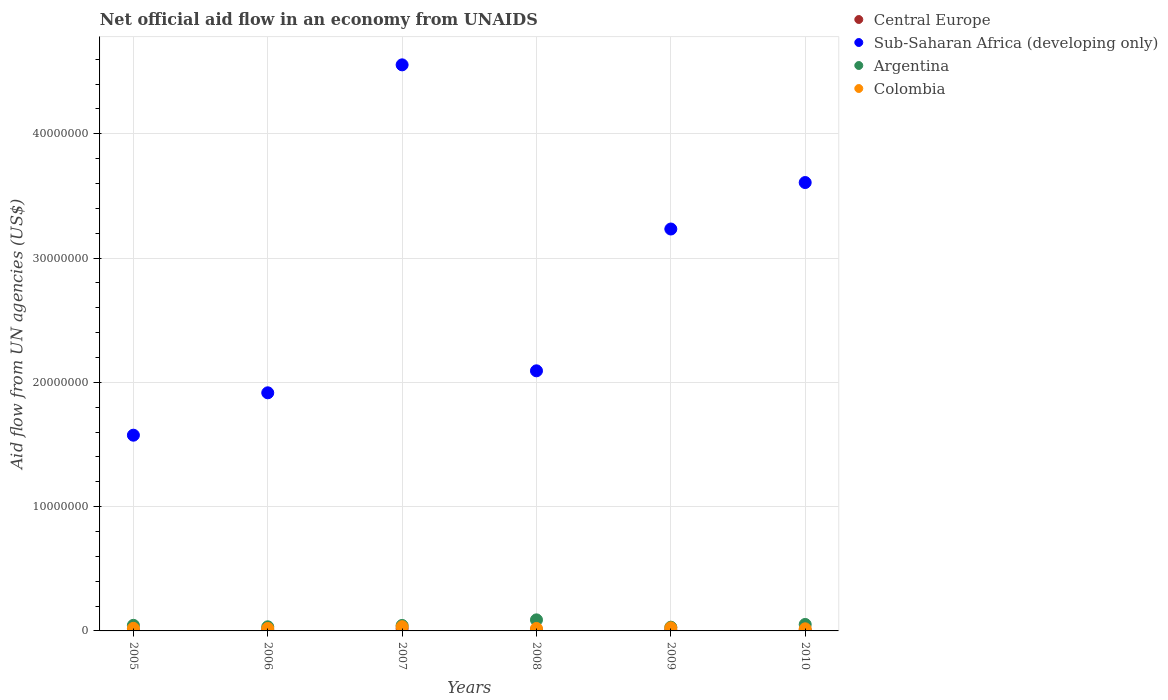How many different coloured dotlines are there?
Your answer should be compact. 4. What is the net official aid flow in Argentina in 2010?
Make the answer very short. 5.20e+05. Across all years, what is the maximum net official aid flow in Argentina?
Ensure brevity in your answer.  8.90e+05. Across all years, what is the minimum net official aid flow in Argentina?
Offer a terse response. 3.00e+05. In which year was the net official aid flow in Sub-Saharan Africa (developing only) maximum?
Your answer should be very brief. 2007. What is the total net official aid flow in Colombia in the graph?
Your response must be concise. 1.37e+06. What is the difference between the net official aid flow in Argentina in 2007 and that in 2009?
Offer a terse response. 1.40e+05. What is the average net official aid flow in Colombia per year?
Your answer should be very brief. 2.28e+05. In the year 2006, what is the difference between the net official aid flow in Argentina and net official aid flow in Colombia?
Provide a succinct answer. 1.30e+05. What is the ratio of the net official aid flow in Central Europe in 2008 to that in 2010?
Ensure brevity in your answer.  1.14. Is the net official aid flow in Colombia in 2006 less than that in 2007?
Give a very brief answer. Yes. What is the difference between the highest and the lowest net official aid flow in Argentina?
Your response must be concise. 5.90e+05. In how many years, is the net official aid flow in Central Europe greater than the average net official aid flow in Central Europe taken over all years?
Keep it short and to the point. 1. Is it the case that in every year, the sum of the net official aid flow in Sub-Saharan Africa (developing only) and net official aid flow in Central Europe  is greater than the sum of net official aid flow in Colombia and net official aid flow in Argentina?
Ensure brevity in your answer.  Yes. Is it the case that in every year, the sum of the net official aid flow in Argentina and net official aid flow in Colombia  is greater than the net official aid flow in Central Europe?
Give a very brief answer. Yes. Is the net official aid flow in Colombia strictly greater than the net official aid flow in Argentina over the years?
Keep it short and to the point. No. How many dotlines are there?
Your answer should be compact. 4. How many years are there in the graph?
Provide a short and direct response. 6. Where does the legend appear in the graph?
Your answer should be compact. Top right. How many legend labels are there?
Your answer should be very brief. 4. What is the title of the graph?
Provide a short and direct response. Net official aid flow in an economy from UNAIDS. What is the label or title of the X-axis?
Your answer should be compact. Years. What is the label or title of the Y-axis?
Your answer should be very brief. Aid flow from UN agencies (US$). What is the Aid flow from UN agencies (US$) of Central Europe in 2005?
Make the answer very short. 5.00e+04. What is the Aid flow from UN agencies (US$) in Sub-Saharan Africa (developing only) in 2005?
Offer a terse response. 1.58e+07. What is the Aid flow from UN agencies (US$) of Argentina in 2005?
Offer a terse response. 4.50e+05. What is the Aid flow from UN agencies (US$) in Sub-Saharan Africa (developing only) in 2006?
Provide a succinct answer. 1.92e+07. What is the Aid flow from UN agencies (US$) in Argentina in 2006?
Keep it short and to the point. 3.30e+05. What is the Aid flow from UN agencies (US$) of Colombia in 2006?
Provide a short and direct response. 2.00e+05. What is the Aid flow from UN agencies (US$) in Central Europe in 2007?
Give a very brief answer. 1.80e+05. What is the Aid flow from UN agencies (US$) of Sub-Saharan Africa (developing only) in 2007?
Keep it short and to the point. 4.56e+07. What is the Aid flow from UN agencies (US$) in Central Europe in 2008?
Your response must be concise. 8.00e+04. What is the Aid flow from UN agencies (US$) in Sub-Saharan Africa (developing only) in 2008?
Give a very brief answer. 2.09e+07. What is the Aid flow from UN agencies (US$) in Argentina in 2008?
Make the answer very short. 8.90e+05. What is the Aid flow from UN agencies (US$) of Sub-Saharan Africa (developing only) in 2009?
Offer a terse response. 3.23e+07. What is the Aid flow from UN agencies (US$) in Argentina in 2009?
Offer a terse response. 3.00e+05. What is the Aid flow from UN agencies (US$) in Colombia in 2009?
Provide a succinct answer. 2.50e+05. What is the Aid flow from UN agencies (US$) in Central Europe in 2010?
Your answer should be very brief. 7.00e+04. What is the Aid flow from UN agencies (US$) in Sub-Saharan Africa (developing only) in 2010?
Offer a terse response. 3.61e+07. What is the Aid flow from UN agencies (US$) in Argentina in 2010?
Keep it short and to the point. 5.20e+05. What is the Aid flow from UN agencies (US$) in Colombia in 2010?
Offer a very short reply. 1.70e+05. Across all years, what is the maximum Aid flow from UN agencies (US$) in Sub-Saharan Africa (developing only)?
Make the answer very short. 4.56e+07. Across all years, what is the maximum Aid flow from UN agencies (US$) in Argentina?
Your response must be concise. 8.90e+05. Across all years, what is the maximum Aid flow from UN agencies (US$) in Colombia?
Ensure brevity in your answer.  3.40e+05. Across all years, what is the minimum Aid flow from UN agencies (US$) in Sub-Saharan Africa (developing only)?
Provide a short and direct response. 1.58e+07. Across all years, what is the minimum Aid flow from UN agencies (US$) of Argentina?
Give a very brief answer. 3.00e+05. What is the total Aid flow from UN agencies (US$) of Central Europe in the graph?
Your answer should be compact. 5.30e+05. What is the total Aid flow from UN agencies (US$) in Sub-Saharan Africa (developing only) in the graph?
Give a very brief answer. 1.70e+08. What is the total Aid flow from UN agencies (US$) of Argentina in the graph?
Offer a very short reply. 2.93e+06. What is the total Aid flow from UN agencies (US$) in Colombia in the graph?
Provide a succinct answer. 1.37e+06. What is the difference between the Aid flow from UN agencies (US$) in Sub-Saharan Africa (developing only) in 2005 and that in 2006?
Your answer should be very brief. -3.41e+06. What is the difference between the Aid flow from UN agencies (US$) of Argentina in 2005 and that in 2006?
Provide a short and direct response. 1.20e+05. What is the difference between the Aid flow from UN agencies (US$) in Central Europe in 2005 and that in 2007?
Give a very brief answer. -1.30e+05. What is the difference between the Aid flow from UN agencies (US$) in Sub-Saharan Africa (developing only) in 2005 and that in 2007?
Ensure brevity in your answer.  -2.98e+07. What is the difference between the Aid flow from UN agencies (US$) in Argentina in 2005 and that in 2007?
Your answer should be very brief. 10000. What is the difference between the Aid flow from UN agencies (US$) of Central Europe in 2005 and that in 2008?
Your answer should be very brief. -3.00e+04. What is the difference between the Aid flow from UN agencies (US$) of Sub-Saharan Africa (developing only) in 2005 and that in 2008?
Keep it short and to the point. -5.18e+06. What is the difference between the Aid flow from UN agencies (US$) of Argentina in 2005 and that in 2008?
Your answer should be very brief. -4.40e+05. What is the difference between the Aid flow from UN agencies (US$) in Sub-Saharan Africa (developing only) in 2005 and that in 2009?
Ensure brevity in your answer.  -1.66e+07. What is the difference between the Aid flow from UN agencies (US$) of Argentina in 2005 and that in 2009?
Your answer should be compact. 1.50e+05. What is the difference between the Aid flow from UN agencies (US$) in Colombia in 2005 and that in 2009?
Your answer should be compact. -4.00e+04. What is the difference between the Aid flow from UN agencies (US$) of Sub-Saharan Africa (developing only) in 2005 and that in 2010?
Your response must be concise. -2.03e+07. What is the difference between the Aid flow from UN agencies (US$) in Argentina in 2005 and that in 2010?
Give a very brief answer. -7.00e+04. What is the difference between the Aid flow from UN agencies (US$) in Sub-Saharan Africa (developing only) in 2006 and that in 2007?
Ensure brevity in your answer.  -2.64e+07. What is the difference between the Aid flow from UN agencies (US$) of Argentina in 2006 and that in 2007?
Offer a very short reply. -1.10e+05. What is the difference between the Aid flow from UN agencies (US$) of Colombia in 2006 and that in 2007?
Keep it short and to the point. -1.40e+05. What is the difference between the Aid flow from UN agencies (US$) in Sub-Saharan Africa (developing only) in 2006 and that in 2008?
Your answer should be compact. -1.77e+06. What is the difference between the Aid flow from UN agencies (US$) of Argentina in 2006 and that in 2008?
Provide a succinct answer. -5.60e+05. What is the difference between the Aid flow from UN agencies (US$) of Colombia in 2006 and that in 2008?
Give a very brief answer. 0. What is the difference between the Aid flow from UN agencies (US$) in Central Europe in 2006 and that in 2009?
Your answer should be compact. 10000. What is the difference between the Aid flow from UN agencies (US$) of Sub-Saharan Africa (developing only) in 2006 and that in 2009?
Provide a short and direct response. -1.32e+07. What is the difference between the Aid flow from UN agencies (US$) in Colombia in 2006 and that in 2009?
Your response must be concise. -5.00e+04. What is the difference between the Aid flow from UN agencies (US$) in Sub-Saharan Africa (developing only) in 2006 and that in 2010?
Make the answer very short. -1.69e+07. What is the difference between the Aid flow from UN agencies (US$) in Argentina in 2006 and that in 2010?
Provide a short and direct response. -1.90e+05. What is the difference between the Aid flow from UN agencies (US$) of Central Europe in 2007 and that in 2008?
Offer a terse response. 1.00e+05. What is the difference between the Aid flow from UN agencies (US$) of Sub-Saharan Africa (developing only) in 2007 and that in 2008?
Your response must be concise. 2.46e+07. What is the difference between the Aid flow from UN agencies (US$) in Argentina in 2007 and that in 2008?
Your response must be concise. -4.50e+05. What is the difference between the Aid flow from UN agencies (US$) of Central Europe in 2007 and that in 2009?
Offer a very short reply. 1.10e+05. What is the difference between the Aid flow from UN agencies (US$) of Sub-Saharan Africa (developing only) in 2007 and that in 2009?
Make the answer very short. 1.32e+07. What is the difference between the Aid flow from UN agencies (US$) in Argentina in 2007 and that in 2009?
Make the answer very short. 1.40e+05. What is the difference between the Aid flow from UN agencies (US$) in Sub-Saharan Africa (developing only) in 2007 and that in 2010?
Provide a succinct answer. 9.47e+06. What is the difference between the Aid flow from UN agencies (US$) in Central Europe in 2008 and that in 2009?
Keep it short and to the point. 10000. What is the difference between the Aid flow from UN agencies (US$) of Sub-Saharan Africa (developing only) in 2008 and that in 2009?
Ensure brevity in your answer.  -1.14e+07. What is the difference between the Aid flow from UN agencies (US$) in Argentina in 2008 and that in 2009?
Ensure brevity in your answer.  5.90e+05. What is the difference between the Aid flow from UN agencies (US$) in Colombia in 2008 and that in 2009?
Provide a short and direct response. -5.00e+04. What is the difference between the Aid flow from UN agencies (US$) in Central Europe in 2008 and that in 2010?
Provide a short and direct response. 10000. What is the difference between the Aid flow from UN agencies (US$) of Sub-Saharan Africa (developing only) in 2008 and that in 2010?
Keep it short and to the point. -1.52e+07. What is the difference between the Aid flow from UN agencies (US$) in Argentina in 2008 and that in 2010?
Offer a very short reply. 3.70e+05. What is the difference between the Aid flow from UN agencies (US$) in Colombia in 2008 and that in 2010?
Give a very brief answer. 3.00e+04. What is the difference between the Aid flow from UN agencies (US$) of Sub-Saharan Africa (developing only) in 2009 and that in 2010?
Make the answer very short. -3.74e+06. What is the difference between the Aid flow from UN agencies (US$) of Argentina in 2009 and that in 2010?
Your answer should be very brief. -2.20e+05. What is the difference between the Aid flow from UN agencies (US$) of Central Europe in 2005 and the Aid flow from UN agencies (US$) of Sub-Saharan Africa (developing only) in 2006?
Offer a terse response. -1.91e+07. What is the difference between the Aid flow from UN agencies (US$) in Central Europe in 2005 and the Aid flow from UN agencies (US$) in Argentina in 2006?
Your response must be concise. -2.80e+05. What is the difference between the Aid flow from UN agencies (US$) of Sub-Saharan Africa (developing only) in 2005 and the Aid flow from UN agencies (US$) of Argentina in 2006?
Ensure brevity in your answer.  1.54e+07. What is the difference between the Aid flow from UN agencies (US$) in Sub-Saharan Africa (developing only) in 2005 and the Aid flow from UN agencies (US$) in Colombia in 2006?
Give a very brief answer. 1.56e+07. What is the difference between the Aid flow from UN agencies (US$) in Central Europe in 2005 and the Aid flow from UN agencies (US$) in Sub-Saharan Africa (developing only) in 2007?
Make the answer very short. -4.55e+07. What is the difference between the Aid flow from UN agencies (US$) of Central Europe in 2005 and the Aid flow from UN agencies (US$) of Argentina in 2007?
Ensure brevity in your answer.  -3.90e+05. What is the difference between the Aid flow from UN agencies (US$) of Sub-Saharan Africa (developing only) in 2005 and the Aid flow from UN agencies (US$) of Argentina in 2007?
Your response must be concise. 1.53e+07. What is the difference between the Aid flow from UN agencies (US$) of Sub-Saharan Africa (developing only) in 2005 and the Aid flow from UN agencies (US$) of Colombia in 2007?
Your response must be concise. 1.54e+07. What is the difference between the Aid flow from UN agencies (US$) of Argentina in 2005 and the Aid flow from UN agencies (US$) of Colombia in 2007?
Make the answer very short. 1.10e+05. What is the difference between the Aid flow from UN agencies (US$) of Central Europe in 2005 and the Aid flow from UN agencies (US$) of Sub-Saharan Africa (developing only) in 2008?
Provide a succinct answer. -2.09e+07. What is the difference between the Aid flow from UN agencies (US$) in Central Europe in 2005 and the Aid flow from UN agencies (US$) in Argentina in 2008?
Give a very brief answer. -8.40e+05. What is the difference between the Aid flow from UN agencies (US$) in Central Europe in 2005 and the Aid flow from UN agencies (US$) in Colombia in 2008?
Your response must be concise. -1.50e+05. What is the difference between the Aid flow from UN agencies (US$) of Sub-Saharan Africa (developing only) in 2005 and the Aid flow from UN agencies (US$) of Argentina in 2008?
Make the answer very short. 1.49e+07. What is the difference between the Aid flow from UN agencies (US$) of Sub-Saharan Africa (developing only) in 2005 and the Aid flow from UN agencies (US$) of Colombia in 2008?
Make the answer very short. 1.56e+07. What is the difference between the Aid flow from UN agencies (US$) in Central Europe in 2005 and the Aid flow from UN agencies (US$) in Sub-Saharan Africa (developing only) in 2009?
Offer a very short reply. -3.23e+07. What is the difference between the Aid flow from UN agencies (US$) of Central Europe in 2005 and the Aid flow from UN agencies (US$) of Colombia in 2009?
Give a very brief answer. -2.00e+05. What is the difference between the Aid flow from UN agencies (US$) in Sub-Saharan Africa (developing only) in 2005 and the Aid flow from UN agencies (US$) in Argentina in 2009?
Your response must be concise. 1.54e+07. What is the difference between the Aid flow from UN agencies (US$) of Sub-Saharan Africa (developing only) in 2005 and the Aid flow from UN agencies (US$) of Colombia in 2009?
Your answer should be compact. 1.55e+07. What is the difference between the Aid flow from UN agencies (US$) in Argentina in 2005 and the Aid flow from UN agencies (US$) in Colombia in 2009?
Keep it short and to the point. 2.00e+05. What is the difference between the Aid flow from UN agencies (US$) of Central Europe in 2005 and the Aid flow from UN agencies (US$) of Sub-Saharan Africa (developing only) in 2010?
Give a very brief answer. -3.60e+07. What is the difference between the Aid flow from UN agencies (US$) in Central Europe in 2005 and the Aid flow from UN agencies (US$) in Argentina in 2010?
Offer a terse response. -4.70e+05. What is the difference between the Aid flow from UN agencies (US$) of Sub-Saharan Africa (developing only) in 2005 and the Aid flow from UN agencies (US$) of Argentina in 2010?
Offer a terse response. 1.52e+07. What is the difference between the Aid flow from UN agencies (US$) in Sub-Saharan Africa (developing only) in 2005 and the Aid flow from UN agencies (US$) in Colombia in 2010?
Your answer should be very brief. 1.56e+07. What is the difference between the Aid flow from UN agencies (US$) in Central Europe in 2006 and the Aid flow from UN agencies (US$) in Sub-Saharan Africa (developing only) in 2007?
Give a very brief answer. -4.55e+07. What is the difference between the Aid flow from UN agencies (US$) in Central Europe in 2006 and the Aid flow from UN agencies (US$) in Argentina in 2007?
Provide a succinct answer. -3.60e+05. What is the difference between the Aid flow from UN agencies (US$) in Sub-Saharan Africa (developing only) in 2006 and the Aid flow from UN agencies (US$) in Argentina in 2007?
Give a very brief answer. 1.87e+07. What is the difference between the Aid flow from UN agencies (US$) of Sub-Saharan Africa (developing only) in 2006 and the Aid flow from UN agencies (US$) of Colombia in 2007?
Your answer should be compact. 1.88e+07. What is the difference between the Aid flow from UN agencies (US$) in Central Europe in 2006 and the Aid flow from UN agencies (US$) in Sub-Saharan Africa (developing only) in 2008?
Give a very brief answer. -2.08e+07. What is the difference between the Aid flow from UN agencies (US$) of Central Europe in 2006 and the Aid flow from UN agencies (US$) of Argentina in 2008?
Your response must be concise. -8.10e+05. What is the difference between the Aid flow from UN agencies (US$) in Central Europe in 2006 and the Aid flow from UN agencies (US$) in Colombia in 2008?
Offer a terse response. -1.20e+05. What is the difference between the Aid flow from UN agencies (US$) of Sub-Saharan Africa (developing only) in 2006 and the Aid flow from UN agencies (US$) of Argentina in 2008?
Offer a terse response. 1.83e+07. What is the difference between the Aid flow from UN agencies (US$) in Sub-Saharan Africa (developing only) in 2006 and the Aid flow from UN agencies (US$) in Colombia in 2008?
Your answer should be very brief. 1.90e+07. What is the difference between the Aid flow from UN agencies (US$) in Argentina in 2006 and the Aid flow from UN agencies (US$) in Colombia in 2008?
Your answer should be compact. 1.30e+05. What is the difference between the Aid flow from UN agencies (US$) of Central Europe in 2006 and the Aid flow from UN agencies (US$) of Sub-Saharan Africa (developing only) in 2009?
Provide a succinct answer. -3.23e+07. What is the difference between the Aid flow from UN agencies (US$) of Central Europe in 2006 and the Aid flow from UN agencies (US$) of Argentina in 2009?
Keep it short and to the point. -2.20e+05. What is the difference between the Aid flow from UN agencies (US$) in Sub-Saharan Africa (developing only) in 2006 and the Aid flow from UN agencies (US$) in Argentina in 2009?
Make the answer very short. 1.89e+07. What is the difference between the Aid flow from UN agencies (US$) of Sub-Saharan Africa (developing only) in 2006 and the Aid flow from UN agencies (US$) of Colombia in 2009?
Make the answer very short. 1.89e+07. What is the difference between the Aid flow from UN agencies (US$) in Argentina in 2006 and the Aid flow from UN agencies (US$) in Colombia in 2009?
Offer a terse response. 8.00e+04. What is the difference between the Aid flow from UN agencies (US$) of Central Europe in 2006 and the Aid flow from UN agencies (US$) of Sub-Saharan Africa (developing only) in 2010?
Make the answer very short. -3.60e+07. What is the difference between the Aid flow from UN agencies (US$) in Central Europe in 2006 and the Aid flow from UN agencies (US$) in Argentina in 2010?
Offer a very short reply. -4.40e+05. What is the difference between the Aid flow from UN agencies (US$) of Sub-Saharan Africa (developing only) in 2006 and the Aid flow from UN agencies (US$) of Argentina in 2010?
Your response must be concise. 1.86e+07. What is the difference between the Aid flow from UN agencies (US$) in Sub-Saharan Africa (developing only) in 2006 and the Aid flow from UN agencies (US$) in Colombia in 2010?
Offer a terse response. 1.90e+07. What is the difference between the Aid flow from UN agencies (US$) of Argentina in 2006 and the Aid flow from UN agencies (US$) of Colombia in 2010?
Give a very brief answer. 1.60e+05. What is the difference between the Aid flow from UN agencies (US$) of Central Europe in 2007 and the Aid flow from UN agencies (US$) of Sub-Saharan Africa (developing only) in 2008?
Provide a short and direct response. -2.08e+07. What is the difference between the Aid flow from UN agencies (US$) of Central Europe in 2007 and the Aid flow from UN agencies (US$) of Argentina in 2008?
Provide a short and direct response. -7.10e+05. What is the difference between the Aid flow from UN agencies (US$) of Central Europe in 2007 and the Aid flow from UN agencies (US$) of Colombia in 2008?
Your answer should be compact. -2.00e+04. What is the difference between the Aid flow from UN agencies (US$) in Sub-Saharan Africa (developing only) in 2007 and the Aid flow from UN agencies (US$) in Argentina in 2008?
Keep it short and to the point. 4.47e+07. What is the difference between the Aid flow from UN agencies (US$) in Sub-Saharan Africa (developing only) in 2007 and the Aid flow from UN agencies (US$) in Colombia in 2008?
Keep it short and to the point. 4.54e+07. What is the difference between the Aid flow from UN agencies (US$) in Argentina in 2007 and the Aid flow from UN agencies (US$) in Colombia in 2008?
Make the answer very short. 2.40e+05. What is the difference between the Aid flow from UN agencies (US$) of Central Europe in 2007 and the Aid flow from UN agencies (US$) of Sub-Saharan Africa (developing only) in 2009?
Offer a terse response. -3.22e+07. What is the difference between the Aid flow from UN agencies (US$) of Sub-Saharan Africa (developing only) in 2007 and the Aid flow from UN agencies (US$) of Argentina in 2009?
Provide a short and direct response. 4.52e+07. What is the difference between the Aid flow from UN agencies (US$) in Sub-Saharan Africa (developing only) in 2007 and the Aid flow from UN agencies (US$) in Colombia in 2009?
Ensure brevity in your answer.  4.53e+07. What is the difference between the Aid flow from UN agencies (US$) of Argentina in 2007 and the Aid flow from UN agencies (US$) of Colombia in 2009?
Your response must be concise. 1.90e+05. What is the difference between the Aid flow from UN agencies (US$) of Central Europe in 2007 and the Aid flow from UN agencies (US$) of Sub-Saharan Africa (developing only) in 2010?
Keep it short and to the point. -3.59e+07. What is the difference between the Aid flow from UN agencies (US$) in Central Europe in 2007 and the Aid flow from UN agencies (US$) in Argentina in 2010?
Keep it short and to the point. -3.40e+05. What is the difference between the Aid flow from UN agencies (US$) in Sub-Saharan Africa (developing only) in 2007 and the Aid flow from UN agencies (US$) in Argentina in 2010?
Provide a succinct answer. 4.50e+07. What is the difference between the Aid flow from UN agencies (US$) of Sub-Saharan Africa (developing only) in 2007 and the Aid flow from UN agencies (US$) of Colombia in 2010?
Your answer should be very brief. 4.54e+07. What is the difference between the Aid flow from UN agencies (US$) in Central Europe in 2008 and the Aid flow from UN agencies (US$) in Sub-Saharan Africa (developing only) in 2009?
Provide a short and direct response. -3.23e+07. What is the difference between the Aid flow from UN agencies (US$) of Central Europe in 2008 and the Aid flow from UN agencies (US$) of Argentina in 2009?
Make the answer very short. -2.20e+05. What is the difference between the Aid flow from UN agencies (US$) of Central Europe in 2008 and the Aid flow from UN agencies (US$) of Colombia in 2009?
Provide a succinct answer. -1.70e+05. What is the difference between the Aid flow from UN agencies (US$) of Sub-Saharan Africa (developing only) in 2008 and the Aid flow from UN agencies (US$) of Argentina in 2009?
Your answer should be compact. 2.06e+07. What is the difference between the Aid flow from UN agencies (US$) of Sub-Saharan Africa (developing only) in 2008 and the Aid flow from UN agencies (US$) of Colombia in 2009?
Your answer should be very brief. 2.07e+07. What is the difference between the Aid flow from UN agencies (US$) in Argentina in 2008 and the Aid flow from UN agencies (US$) in Colombia in 2009?
Give a very brief answer. 6.40e+05. What is the difference between the Aid flow from UN agencies (US$) of Central Europe in 2008 and the Aid flow from UN agencies (US$) of Sub-Saharan Africa (developing only) in 2010?
Provide a succinct answer. -3.60e+07. What is the difference between the Aid flow from UN agencies (US$) in Central Europe in 2008 and the Aid flow from UN agencies (US$) in Argentina in 2010?
Offer a terse response. -4.40e+05. What is the difference between the Aid flow from UN agencies (US$) in Sub-Saharan Africa (developing only) in 2008 and the Aid flow from UN agencies (US$) in Argentina in 2010?
Offer a terse response. 2.04e+07. What is the difference between the Aid flow from UN agencies (US$) of Sub-Saharan Africa (developing only) in 2008 and the Aid flow from UN agencies (US$) of Colombia in 2010?
Offer a very short reply. 2.08e+07. What is the difference between the Aid flow from UN agencies (US$) of Argentina in 2008 and the Aid flow from UN agencies (US$) of Colombia in 2010?
Your answer should be very brief. 7.20e+05. What is the difference between the Aid flow from UN agencies (US$) of Central Europe in 2009 and the Aid flow from UN agencies (US$) of Sub-Saharan Africa (developing only) in 2010?
Your answer should be compact. -3.60e+07. What is the difference between the Aid flow from UN agencies (US$) of Central Europe in 2009 and the Aid flow from UN agencies (US$) of Argentina in 2010?
Offer a terse response. -4.50e+05. What is the difference between the Aid flow from UN agencies (US$) of Sub-Saharan Africa (developing only) in 2009 and the Aid flow from UN agencies (US$) of Argentina in 2010?
Provide a short and direct response. 3.18e+07. What is the difference between the Aid flow from UN agencies (US$) in Sub-Saharan Africa (developing only) in 2009 and the Aid flow from UN agencies (US$) in Colombia in 2010?
Provide a short and direct response. 3.22e+07. What is the average Aid flow from UN agencies (US$) in Central Europe per year?
Provide a short and direct response. 8.83e+04. What is the average Aid flow from UN agencies (US$) in Sub-Saharan Africa (developing only) per year?
Make the answer very short. 2.83e+07. What is the average Aid flow from UN agencies (US$) of Argentina per year?
Give a very brief answer. 4.88e+05. What is the average Aid flow from UN agencies (US$) in Colombia per year?
Keep it short and to the point. 2.28e+05. In the year 2005, what is the difference between the Aid flow from UN agencies (US$) in Central Europe and Aid flow from UN agencies (US$) in Sub-Saharan Africa (developing only)?
Your answer should be compact. -1.57e+07. In the year 2005, what is the difference between the Aid flow from UN agencies (US$) of Central Europe and Aid flow from UN agencies (US$) of Argentina?
Make the answer very short. -4.00e+05. In the year 2005, what is the difference between the Aid flow from UN agencies (US$) in Sub-Saharan Africa (developing only) and Aid flow from UN agencies (US$) in Argentina?
Offer a very short reply. 1.53e+07. In the year 2005, what is the difference between the Aid flow from UN agencies (US$) in Sub-Saharan Africa (developing only) and Aid flow from UN agencies (US$) in Colombia?
Give a very brief answer. 1.55e+07. In the year 2005, what is the difference between the Aid flow from UN agencies (US$) in Argentina and Aid flow from UN agencies (US$) in Colombia?
Give a very brief answer. 2.40e+05. In the year 2006, what is the difference between the Aid flow from UN agencies (US$) of Central Europe and Aid flow from UN agencies (US$) of Sub-Saharan Africa (developing only)?
Keep it short and to the point. -1.91e+07. In the year 2006, what is the difference between the Aid flow from UN agencies (US$) of Central Europe and Aid flow from UN agencies (US$) of Argentina?
Offer a terse response. -2.50e+05. In the year 2006, what is the difference between the Aid flow from UN agencies (US$) in Sub-Saharan Africa (developing only) and Aid flow from UN agencies (US$) in Argentina?
Offer a terse response. 1.88e+07. In the year 2006, what is the difference between the Aid flow from UN agencies (US$) in Sub-Saharan Africa (developing only) and Aid flow from UN agencies (US$) in Colombia?
Give a very brief answer. 1.90e+07. In the year 2006, what is the difference between the Aid flow from UN agencies (US$) of Argentina and Aid flow from UN agencies (US$) of Colombia?
Your answer should be very brief. 1.30e+05. In the year 2007, what is the difference between the Aid flow from UN agencies (US$) in Central Europe and Aid flow from UN agencies (US$) in Sub-Saharan Africa (developing only)?
Ensure brevity in your answer.  -4.54e+07. In the year 2007, what is the difference between the Aid flow from UN agencies (US$) in Central Europe and Aid flow from UN agencies (US$) in Argentina?
Your response must be concise. -2.60e+05. In the year 2007, what is the difference between the Aid flow from UN agencies (US$) in Central Europe and Aid flow from UN agencies (US$) in Colombia?
Offer a very short reply. -1.60e+05. In the year 2007, what is the difference between the Aid flow from UN agencies (US$) of Sub-Saharan Africa (developing only) and Aid flow from UN agencies (US$) of Argentina?
Your answer should be compact. 4.51e+07. In the year 2007, what is the difference between the Aid flow from UN agencies (US$) in Sub-Saharan Africa (developing only) and Aid flow from UN agencies (US$) in Colombia?
Keep it short and to the point. 4.52e+07. In the year 2008, what is the difference between the Aid flow from UN agencies (US$) in Central Europe and Aid flow from UN agencies (US$) in Sub-Saharan Africa (developing only)?
Make the answer very short. -2.08e+07. In the year 2008, what is the difference between the Aid flow from UN agencies (US$) in Central Europe and Aid flow from UN agencies (US$) in Argentina?
Your answer should be very brief. -8.10e+05. In the year 2008, what is the difference between the Aid flow from UN agencies (US$) of Sub-Saharan Africa (developing only) and Aid flow from UN agencies (US$) of Argentina?
Offer a terse response. 2.00e+07. In the year 2008, what is the difference between the Aid flow from UN agencies (US$) of Sub-Saharan Africa (developing only) and Aid flow from UN agencies (US$) of Colombia?
Your answer should be very brief. 2.07e+07. In the year 2008, what is the difference between the Aid flow from UN agencies (US$) in Argentina and Aid flow from UN agencies (US$) in Colombia?
Offer a very short reply. 6.90e+05. In the year 2009, what is the difference between the Aid flow from UN agencies (US$) of Central Europe and Aid flow from UN agencies (US$) of Sub-Saharan Africa (developing only)?
Your response must be concise. -3.23e+07. In the year 2009, what is the difference between the Aid flow from UN agencies (US$) of Sub-Saharan Africa (developing only) and Aid flow from UN agencies (US$) of Argentina?
Your response must be concise. 3.20e+07. In the year 2009, what is the difference between the Aid flow from UN agencies (US$) in Sub-Saharan Africa (developing only) and Aid flow from UN agencies (US$) in Colombia?
Provide a succinct answer. 3.21e+07. In the year 2010, what is the difference between the Aid flow from UN agencies (US$) in Central Europe and Aid flow from UN agencies (US$) in Sub-Saharan Africa (developing only)?
Provide a short and direct response. -3.60e+07. In the year 2010, what is the difference between the Aid flow from UN agencies (US$) of Central Europe and Aid flow from UN agencies (US$) of Argentina?
Offer a very short reply. -4.50e+05. In the year 2010, what is the difference between the Aid flow from UN agencies (US$) in Sub-Saharan Africa (developing only) and Aid flow from UN agencies (US$) in Argentina?
Your answer should be very brief. 3.56e+07. In the year 2010, what is the difference between the Aid flow from UN agencies (US$) in Sub-Saharan Africa (developing only) and Aid flow from UN agencies (US$) in Colombia?
Your answer should be very brief. 3.59e+07. In the year 2010, what is the difference between the Aid flow from UN agencies (US$) in Argentina and Aid flow from UN agencies (US$) in Colombia?
Provide a short and direct response. 3.50e+05. What is the ratio of the Aid flow from UN agencies (US$) in Sub-Saharan Africa (developing only) in 2005 to that in 2006?
Ensure brevity in your answer.  0.82. What is the ratio of the Aid flow from UN agencies (US$) in Argentina in 2005 to that in 2006?
Provide a short and direct response. 1.36. What is the ratio of the Aid flow from UN agencies (US$) in Colombia in 2005 to that in 2006?
Give a very brief answer. 1.05. What is the ratio of the Aid flow from UN agencies (US$) in Central Europe in 2005 to that in 2007?
Provide a short and direct response. 0.28. What is the ratio of the Aid flow from UN agencies (US$) in Sub-Saharan Africa (developing only) in 2005 to that in 2007?
Make the answer very short. 0.35. What is the ratio of the Aid flow from UN agencies (US$) of Argentina in 2005 to that in 2007?
Your answer should be compact. 1.02. What is the ratio of the Aid flow from UN agencies (US$) in Colombia in 2005 to that in 2007?
Your response must be concise. 0.62. What is the ratio of the Aid flow from UN agencies (US$) in Sub-Saharan Africa (developing only) in 2005 to that in 2008?
Give a very brief answer. 0.75. What is the ratio of the Aid flow from UN agencies (US$) in Argentina in 2005 to that in 2008?
Your answer should be compact. 0.51. What is the ratio of the Aid flow from UN agencies (US$) in Central Europe in 2005 to that in 2009?
Ensure brevity in your answer.  0.71. What is the ratio of the Aid flow from UN agencies (US$) in Sub-Saharan Africa (developing only) in 2005 to that in 2009?
Your answer should be compact. 0.49. What is the ratio of the Aid flow from UN agencies (US$) of Argentina in 2005 to that in 2009?
Keep it short and to the point. 1.5. What is the ratio of the Aid flow from UN agencies (US$) in Colombia in 2005 to that in 2009?
Provide a succinct answer. 0.84. What is the ratio of the Aid flow from UN agencies (US$) of Sub-Saharan Africa (developing only) in 2005 to that in 2010?
Offer a terse response. 0.44. What is the ratio of the Aid flow from UN agencies (US$) of Argentina in 2005 to that in 2010?
Provide a succinct answer. 0.87. What is the ratio of the Aid flow from UN agencies (US$) of Colombia in 2005 to that in 2010?
Provide a short and direct response. 1.24. What is the ratio of the Aid flow from UN agencies (US$) of Central Europe in 2006 to that in 2007?
Provide a succinct answer. 0.44. What is the ratio of the Aid flow from UN agencies (US$) in Sub-Saharan Africa (developing only) in 2006 to that in 2007?
Keep it short and to the point. 0.42. What is the ratio of the Aid flow from UN agencies (US$) of Colombia in 2006 to that in 2007?
Offer a terse response. 0.59. What is the ratio of the Aid flow from UN agencies (US$) in Sub-Saharan Africa (developing only) in 2006 to that in 2008?
Offer a terse response. 0.92. What is the ratio of the Aid flow from UN agencies (US$) in Argentina in 2006 to that in 2008?
Provide a short and direct response. 0.37. What is the ratio of the Aid flow from UN agencies (US$) of Colombia in 2006 to that in 2008?
Provide a succinct answer. 1. What is the ratio of the Aid flow from UN agencies (US$) in Sub-Saharan Africa (developing only) in 2006 to that in 2009?
Make the answer very short. 0.59. What is the ratio of the Aid flow from UN agencies (US$) of Argentina in 2006 to that in 2009?
Your answer should be compact. 1.1. What is the ratio of the Aid flow from UN agencies (US$) of Colombia in 2006 to that in 2009?
Provide a short and direct response. 0.8. What is the ratio of the Aid flow from UN agencies (US$) in Sub-Saharan Africa (developing only) in 2006 to that in 2010?
Provide a short and direct response. 0.53. What is the ratio of the Aid flow from UN agencies (US$) in Argentina in 2006 to that in 2010?
Offer a very short reply. 0.63. What is the ratio of the Aid flow from UN agencies (US$) of Colombia in 2006 to that in 2010?
Your answer should be compact. 1.18. What is the ratio of the Aid flow from UN agencies (US$) in Central Europe in 2007 to that in 2008?
Your response must be concise. 2.25. What is the ratio of the Aid flow from UN agencies (US$) of Sub-Saharan Africa (developing only) in 2007 to that in 2008?
Your response must be concise. 2.18. What is the ratio of the Aid flow from UN agencies (US$) of Argentina in 2007 to that in 2008?
Make the answer very short. 0.49. What is the ratio of the Aid flow from UN agencies (US$) in Colombia in 2007 to that in 2008?
Provide a short and direct response. 1.7. What is the ratio of the Aid flow from UN agencies (US$) in Central Europe in 2007 to that in 2009?
Make the answer very short. 2.57. What is the ratio of the Aid flow from UN agencies (US$) in Sub-Saharan Africa (developing only) in 2007 to that in 2009?
Offer a terse response. 1.41. What is the ratio of the Aid flow from UN agencies (US$) in Argentina in 2007 to that in 2009?
Your response must be concise. 1.47. What is the ratio of the Aid flow from UN agencies (US$) of Colombia in 2007 to that in 2009?
Provide a short and direct response. 1.36. What is the ratio of the Aid flow from UN agencies (US$) of Central Europe in 2007 to that in 2010?
Provide a short and direct response. 2.57. What is the ratio of the Aid flow from UN agencies (US$) in Sub-Saharan Africa (developing only) in 2007 to that in 2010?
Provide a short and direct response. 1.26. What is the ratio of the Aid flow from UN agencies (US$) of Argentina in 2007 to that in 2010?
Provide a short and direct response. 0.85. What is the ratio of the Aid flow from UN agencies (US$) in Central Europe in 2008 to that in 2009?
Your answer should be compact. 1.14. What is the ratio of the Aid flow from UN agencies (US$) in Sub-Saharan Africa (developing only) in 2008 to that in 2009?
Ensure brevity in your answer.  0.65. What is the ratio of the Aid flow from UN agencies (US$) in Argentina in 2008 to that in 2009?
Ensure brevity in your answer.  2.97. What is the ratio of the Aid flow from UN agencies (US$) of Colombia in 2008 to that in 2009?
Ensure brevity in your answer.  0.8. What is the ratio of the Aid flow from UN agencies (US$) of Central Europe in 2008 to that in 2010?
Ensure brevity in your answer.  1.14. What is the ratio of the Aid flow from UN agencies (US$) in Sub-Saharan Africa (developing only) in 2008 to that in 2010?
Make the answer very short. 0.58. What is the ratio of the Aid flow from UN agencies (US$) in Argentina in 2008 to that in 2010?
Ensure brevity in your answer.  1.71. What is the ratio of the Aid flow from UN agencies (US$) of Colombia in 2008 to that in 2010?
Your answer should be very brief. 1.18. What is the ratio of the Aid flow from UN agencies (US$) in Sub-Saharan Africa (developing only) in 2009 to that in 2010?
Your response must be concise. 0.9. What is the ratio of the Aid flow from UN agencies (US$) of Argentina in 2009 to that in 2010?
Ensure brevity in your answer.  0.58. What is the ratio of the Aid flow from UN agencies (US$) of Colombia in 2009 to that in 2010?
Your response must be concise. 1.47. What is the difference between the highest and the second highest Aid flow from UN agencies (US$) in Sub-Saharan Africa (developing only)?
Provide a short and direct response. 9.47e+06. What is the difference between the highest and the second highest Aid flow from UN agencies (US$) of Argentina?
Keep it short and to the point. 3.70e+05. What is the difference between the highest and the second highest Aid flow from UN agencies (US$) of Colombia?
Keep it short and to the point. 9.00e+04. What is the difference between the highest and the lowest Aid flow from UN agencies (US$) of Sub-Saharan Africa (developing only)?
Make the answer very short. 2.98e+07. What is the difference between the highest and the lowest Aid flow from UN agencies (US$) in Argentina?
Your answer should be very brief. 5.90e+05. What is the difference between the highest and the lowest Aid flow from UN agencies (US$) of Colombia?
Make the answer very short. 1.70e+05. 